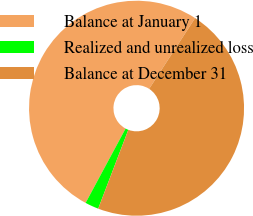Convert chart to OTSL. <chart><loc_0><loc_0><loc_500><loc_500><pie_chart><fcel>Balance at January 1<fcel>Realized and unrealized loss<fcel>Balance at December 31<nl><fcel>51.31%<fcel>2.05%<fcel>46.64%<nl></chart> 